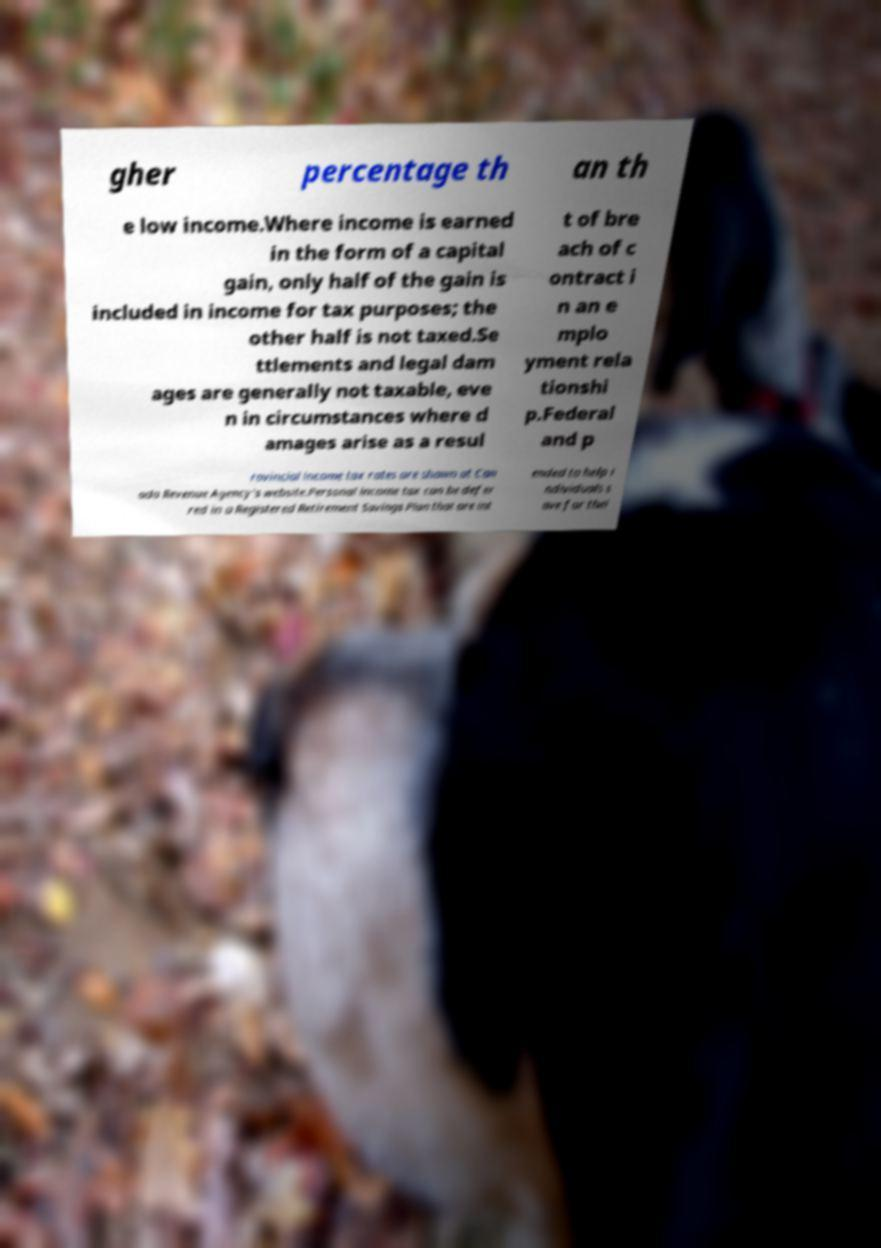There's text embedded in this image that I need extracted. Can you transcribe it verbatim? gher percentage th an th e low income.Where income is earned in the form of a capital gain, only half of the gain is included in income for tax purposes; the other half is not taxed.Se ttlements and legal dam ages are generally not taxable, eve n in circumstances where d amages arise as a resul t of bre ach of c ontract i n an e mplo yment rela tionshi p.Federal and p rovincial income tax rates are shown at Can ada Revenue Agency's website.Personal income tax can be defer red in a Registered Retirement Savings Plan that are int ended to help i ndividuals s ave for thei 